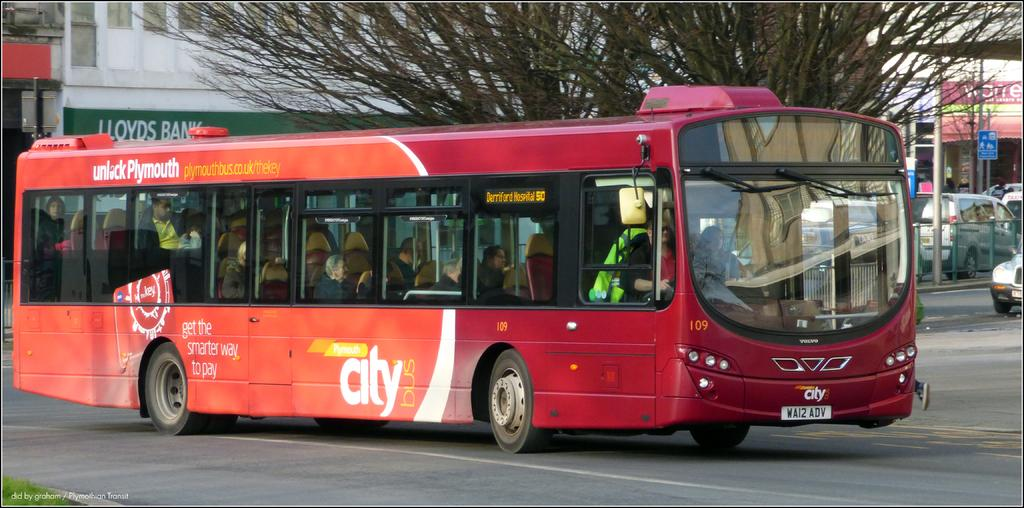Provide a one-sentence caption for the provided image. A red Plymouth city bus drives down the road. 